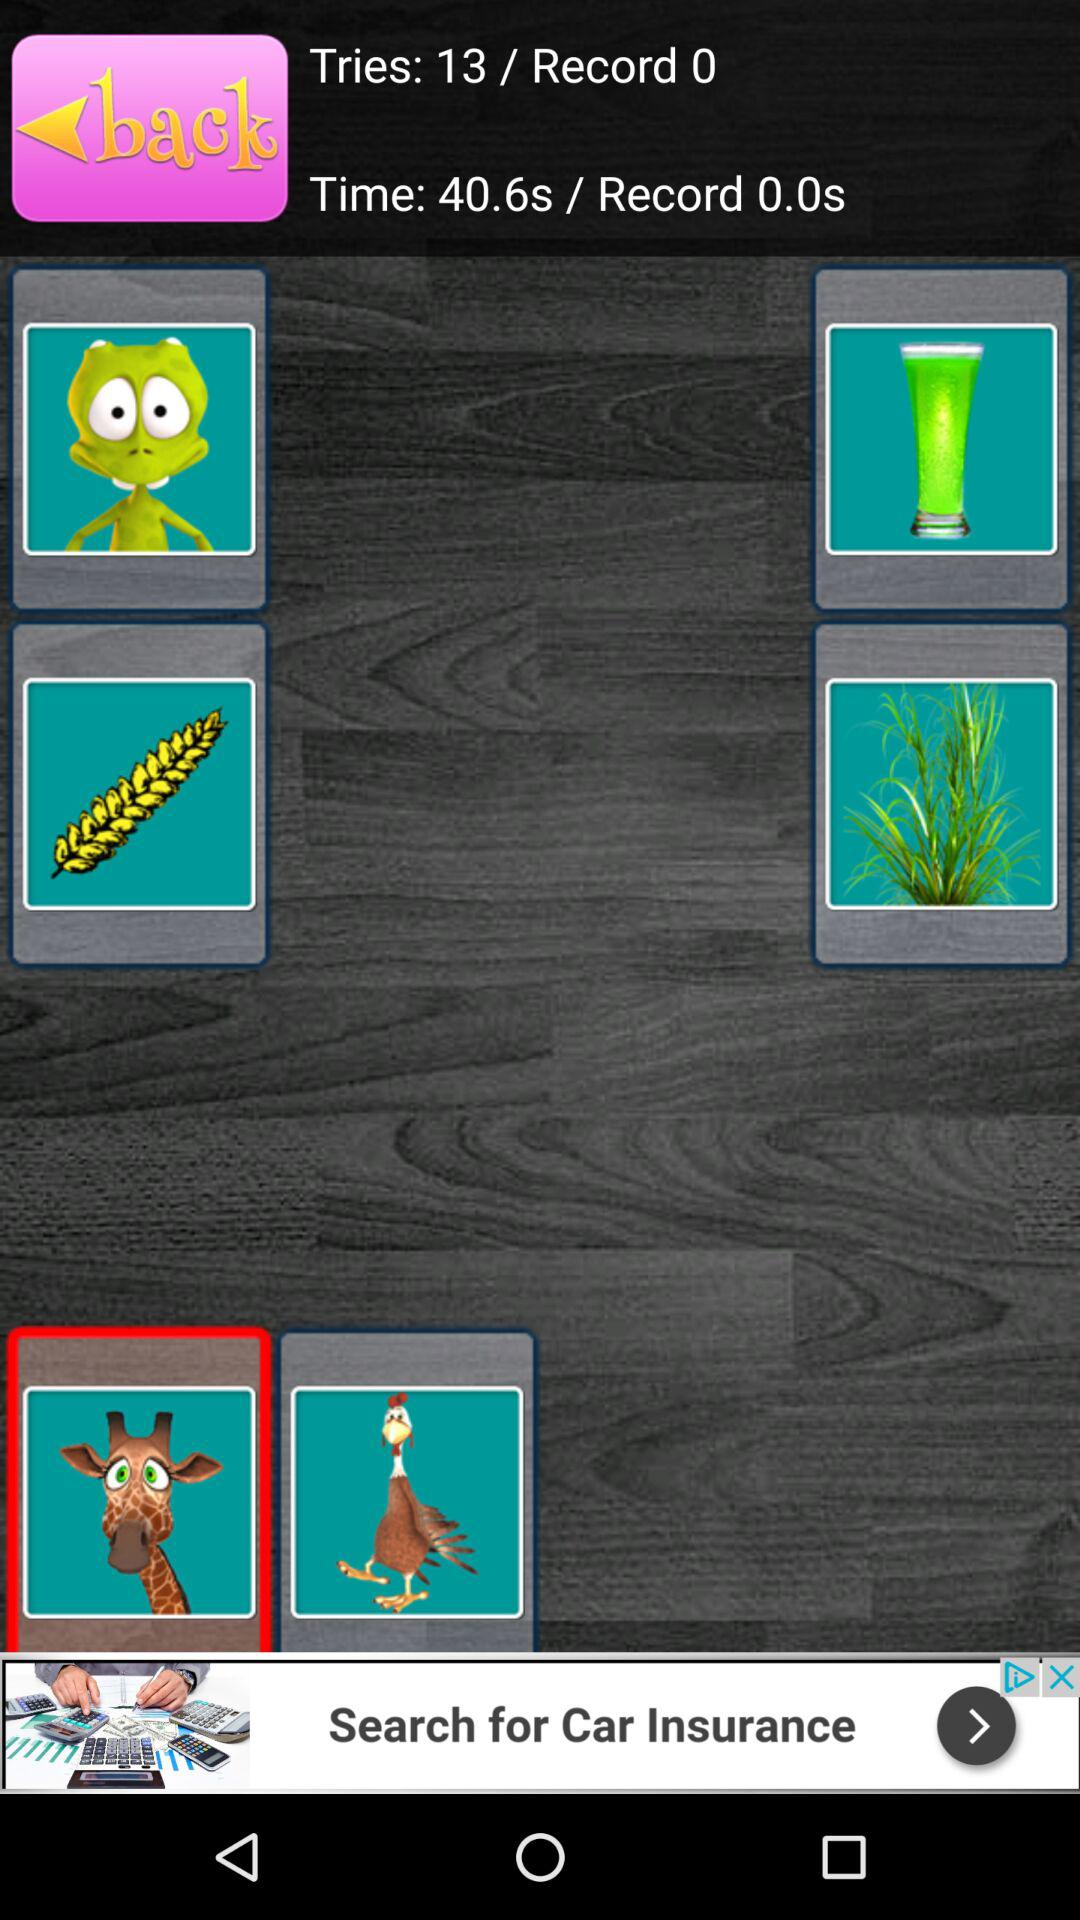What is the number of tries? The number of tries is 13. 